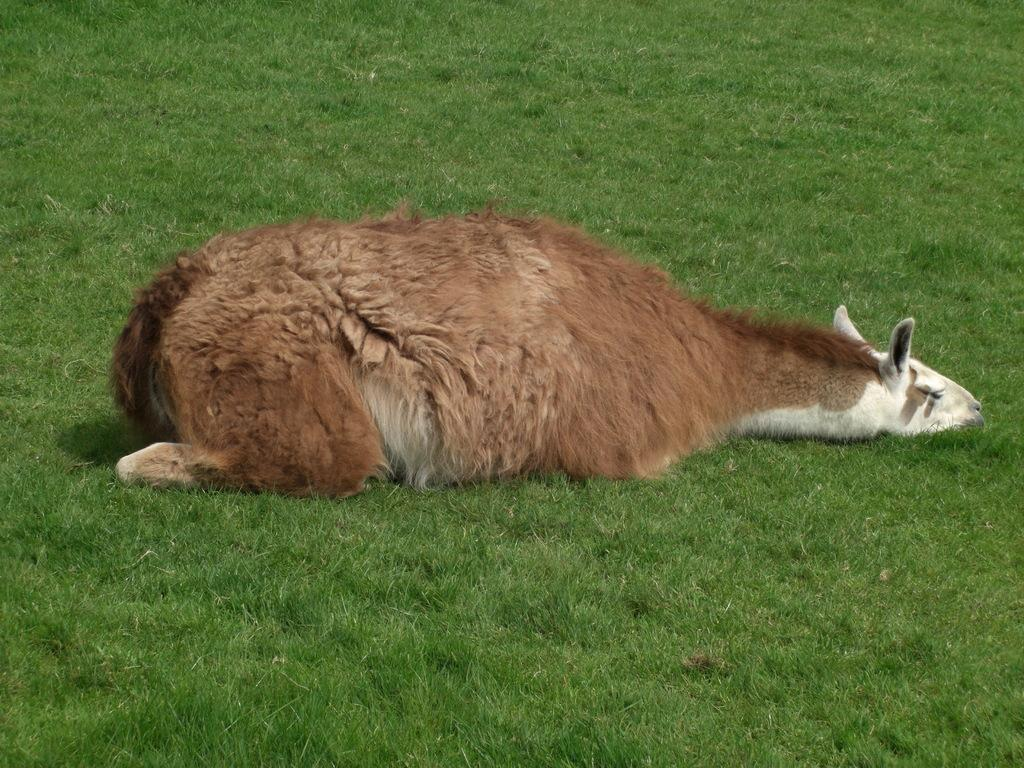What type of creature is in the image? There is an animal in the image. Where is the animal located? The animal is on the ground. What type of vegetation is visible in the image? There is grass visible in the image. How many goldfish are swimming in the grass in the image? There are no goldfish present in the image; it features an animal on the grass. What type of brick structure can be seen in the background of the image? There is no brick structure present in the image; it only features an animal on the grass and grass in the background. 